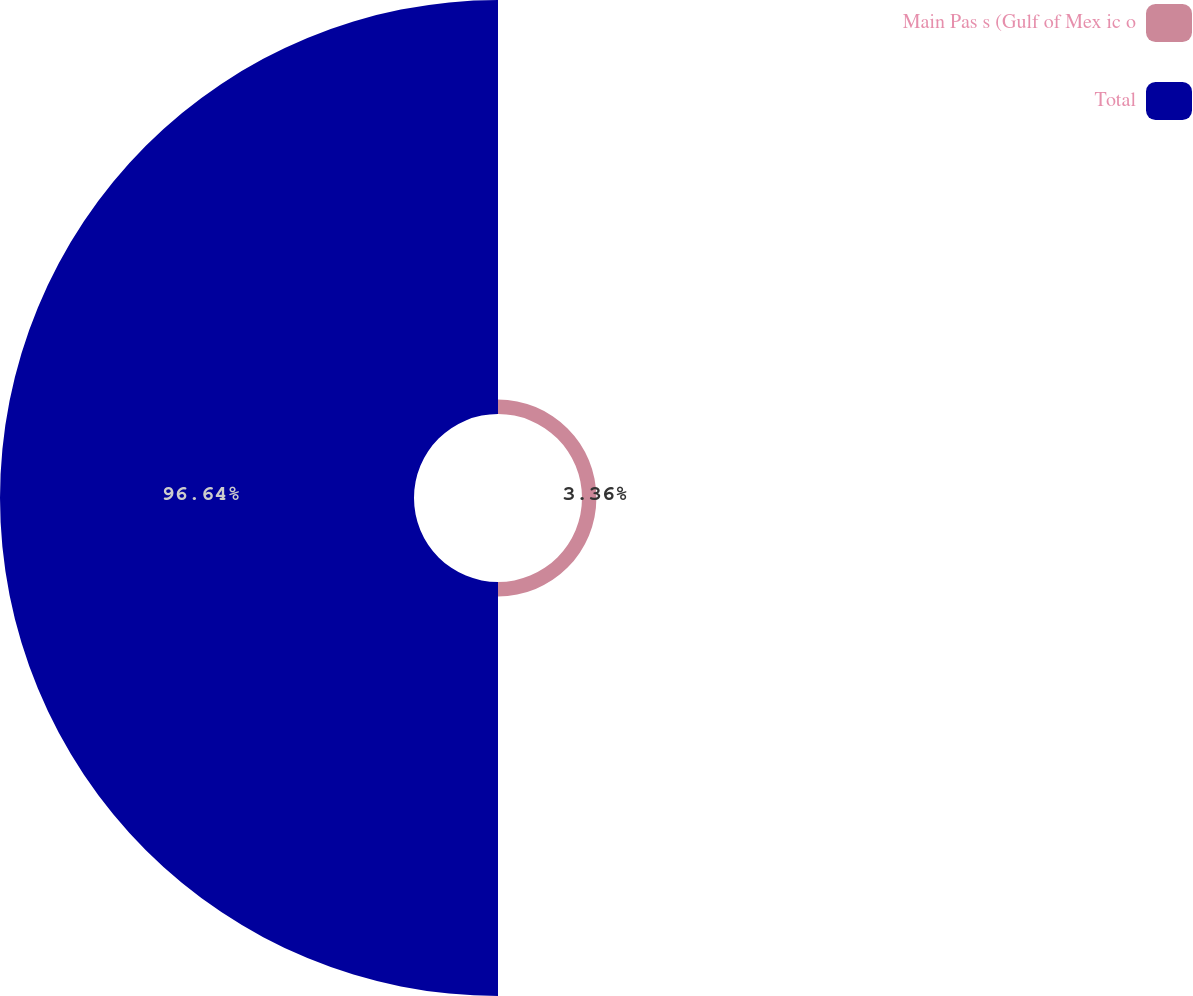Convert chart to OTSL. <chart><loc_0><loc_0><loc_500><loc_500><pie_chart><fcel>Main Pas s (Gulf of Mex ic o<fcel>Total<nl><fcel>3.36%<fcel>96.64%<nl></chart> 